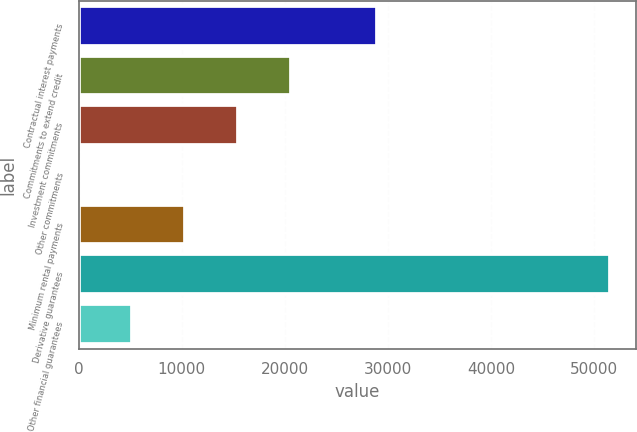Convert chart. <chart><loc_0><loc_0><loc_500><loc_500><bar_chart><fcel>Contractual interest payments<fcel>Commitments to extend credit<fcel>Investment commitments<fcel>Other commitments<fcel>Minimum rental payments<fcel>Derivative guarantees<fcel>Other financial guarantees<nl><fcel>28971<fcel>20628.2<fcel>15481.9<fcel>43<fcel>10335.6<fcel>51506<fcel>5189.3<nl></chart> 